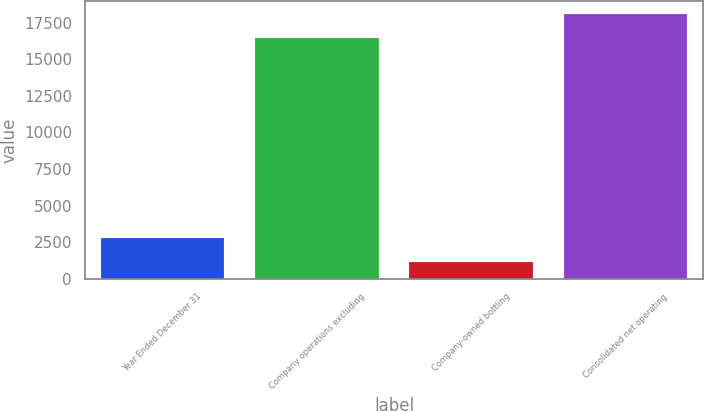Convert chart to OTSL. <chart><loc_0><loc_0><loc_500><loc_500><bar_chart><fcel>Year Ended December 31<fcel>Company operations excluding<fcel>Company-owned bottling<fcel>Consolidated net operating<nl><fcel>2776.9<fcel>16409<fcel>1136<fcel>18049.9<nl></chart> 